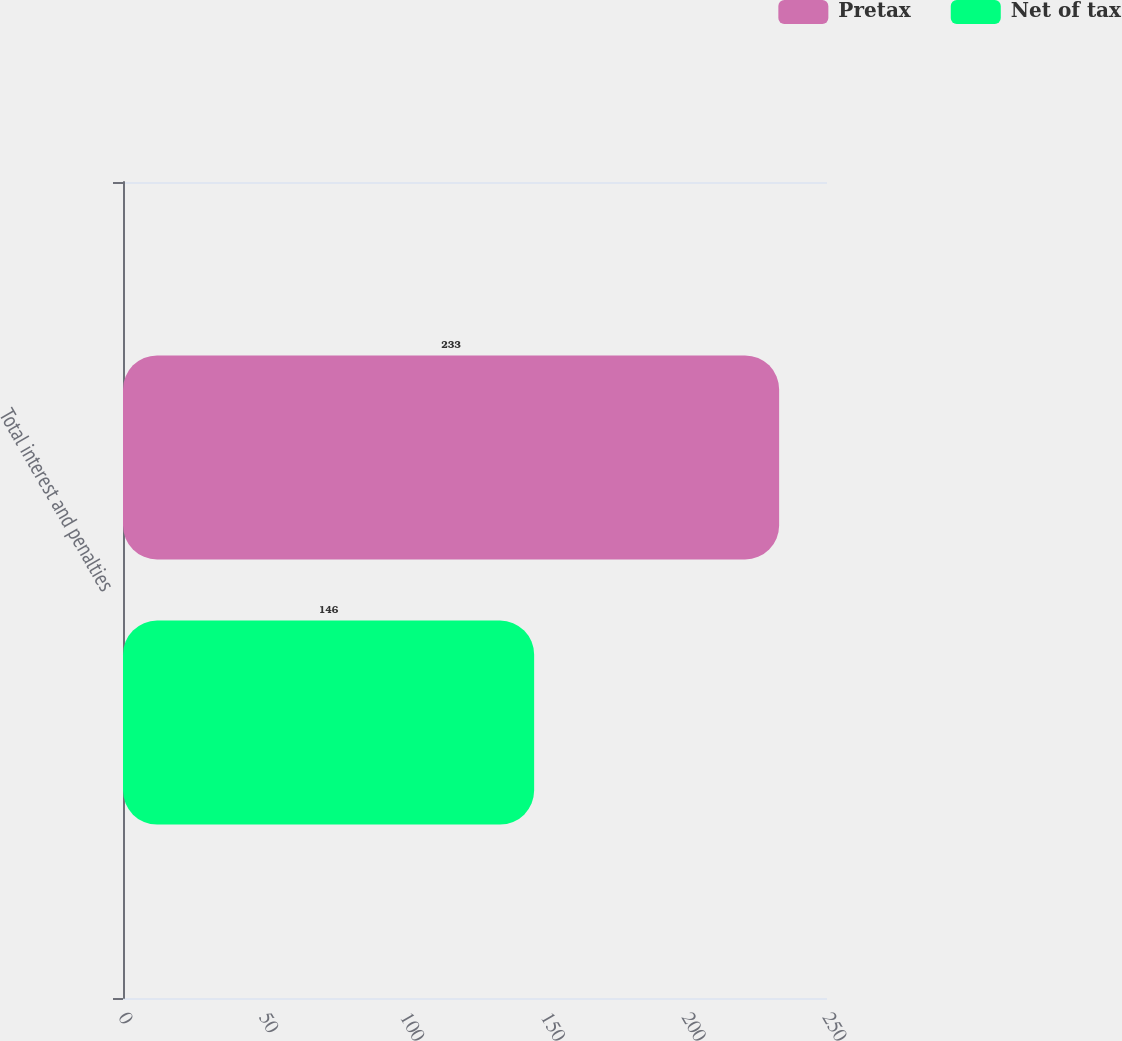Convert chart to OTSL. <chart><loc_0><loc_0><loc_500><loc_500><stacked_bar_chart><ecel><fcel>Total interest and penalties<nl><fcel>Pretax<fcel>233<nl><fcel>Net of tax<fcel>146<nl></chart> 